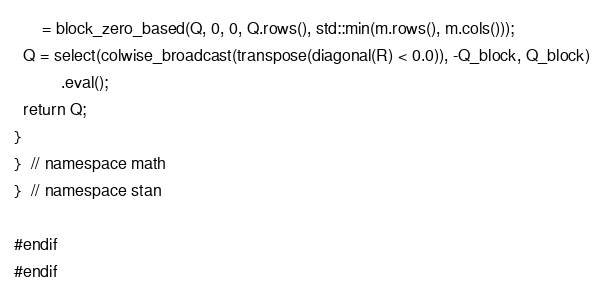<code> <loc_0><loc_0><loc_500><loc_500><_C++_>      = block_zero_based(Q, 0, 0, Q.rows(), std::min(m.rows(), m.cols()));
  Q = select(colwise_broadcast(transpose(diagonal(R) < 0.0)), -Q_block, Q_block)
          .eval();
  return Q;
}
}  // namespace math
}  // namespace stan

#endif
#endif
</code> 